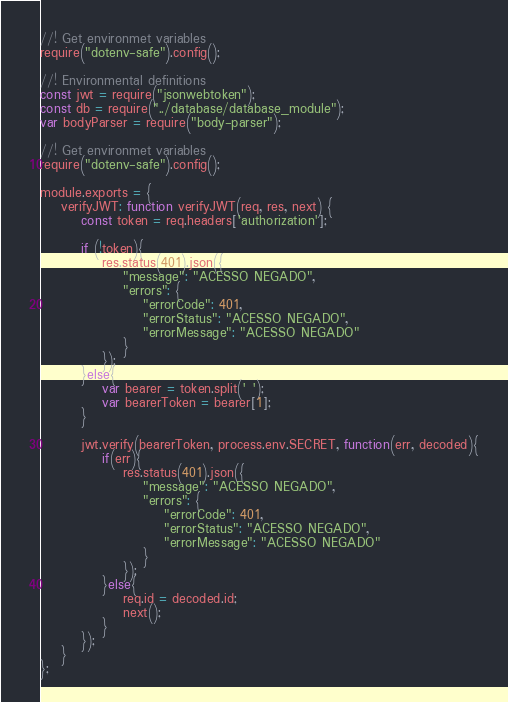<code> <loc_0><loc_0><loc_500><loc_500><_JavaScript_>//! Get environmet variables
require("dotenv-safe").config();

//! Environmental definitions 
const jwt = require("jsonwebtoken");
const db = require("../database/database_module");
var bodyParser = require("body-parser");

//! Get environmet variables
require("dotenv-safe").config();

module.exports = { 
    verifyJWT: function verifyJWT(req, res, next) {
        const token = req.headers['authorization'];

        if (!token){
            res.status(401).json({
                "message": "ACESSO NEGADO",
                "errors": {
                    "errorCode": 401,
                    "errorStatus": "ACESSO NEGADO",
                    "errorMessage": "ACESSO NEGADO"
                }
            });
        }else{
            var bearer = token.split(' ');
            var bearerToken = bearer[1];
        }

        jwt.verify(bearerToken, process.env.SECRET, function(err, decoded){
            if(err){
                res.status(401).json({
                    "message": "ACESSO NEGADO",
                    "errors": {
                        "errorCode": 401,
                        "errorStatus": "ACESSO NEGADO",
                        "errorMessage": "ACESSO NEGADO"
                    }
                });
            }else{
                req.id = decoded.id;
                next();
            }
        });
    }
};
</code> 